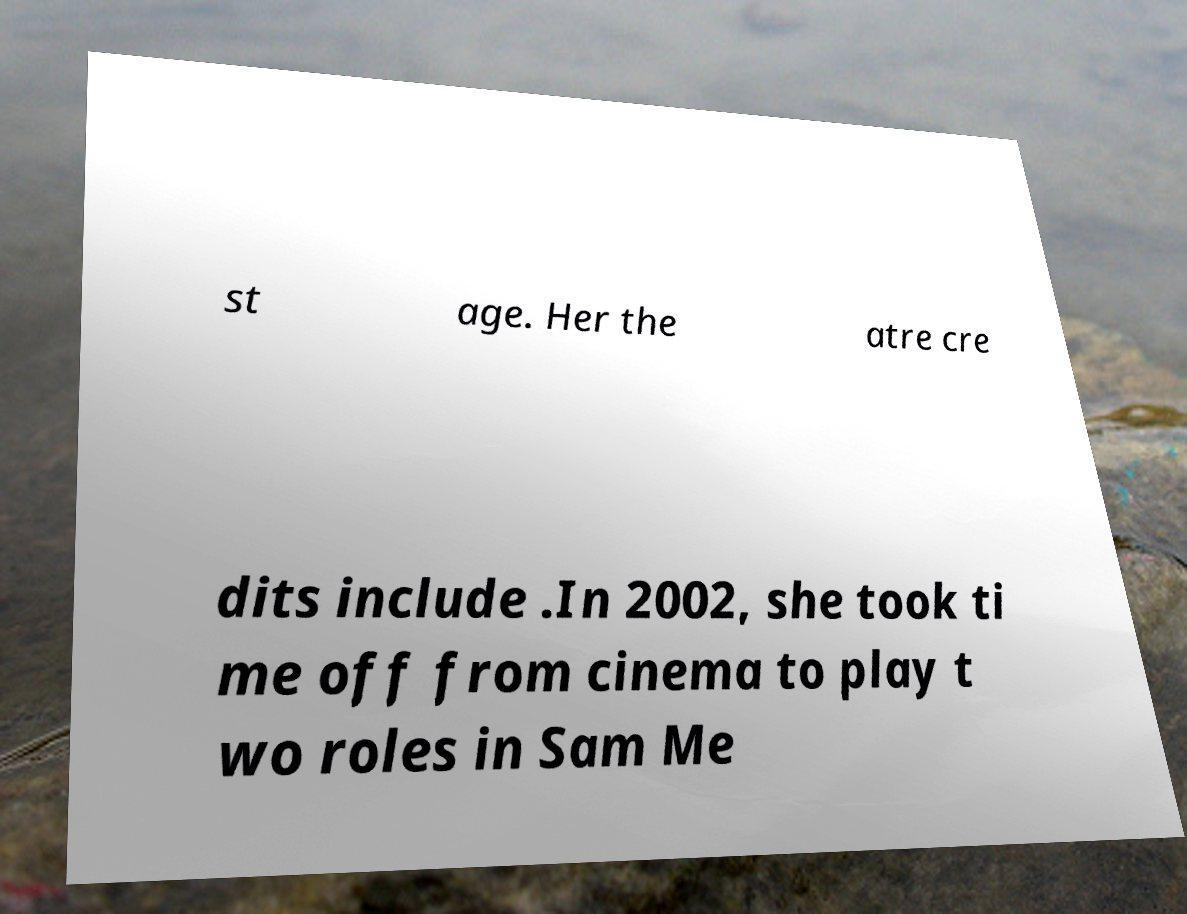Could you extract and type out the text from this image? st age. Her the atre cre dits include .In 2002, she took ti me off from cinema to play t wo roles in Sam Me 